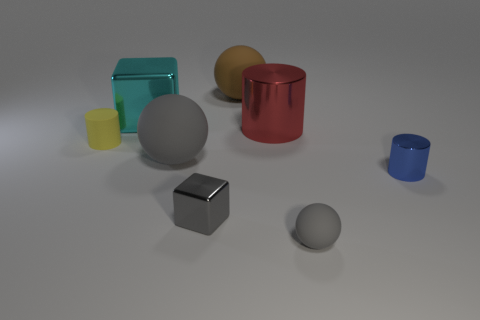Add 2 blue cylinders. How many objects exist? 10 Subtract all cylinders. How many objects are left? 5 Subtract all purple rubber cylinders. Subtract all small gray metallic objects. How many objects are left? 7 Add 4 gray blocks. How many gray blocks are left? 5 Add 6 small rubber cylinders. How many small rubber cylinders exist? 7 Subtract 1 cyan blocks. How many objects are left? 7 